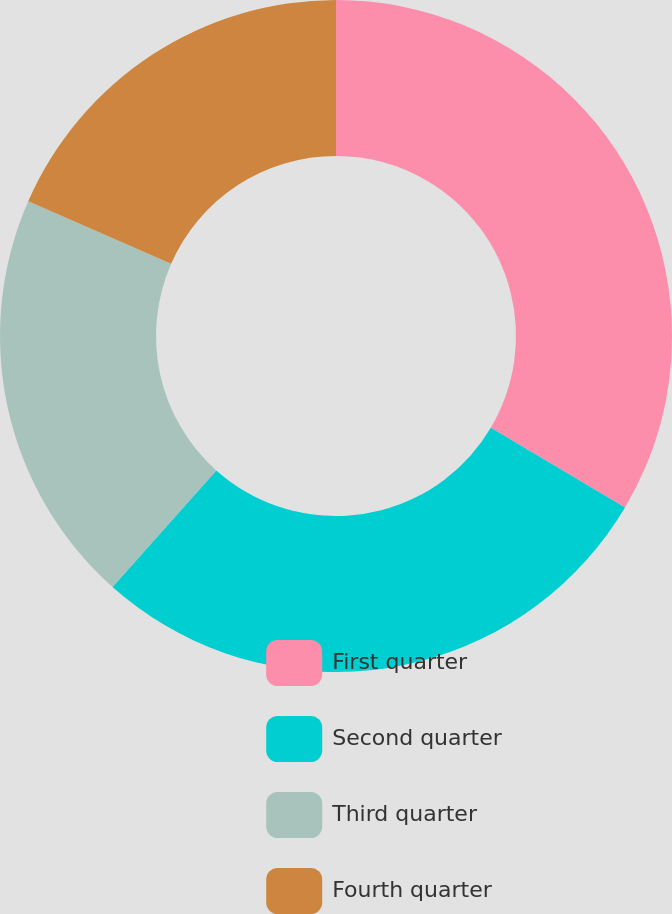<chart> <loc_0><loc_0><loc_500><loc_500><pie_chart><fcel>First quarter<fcel>Second quarter<fcel>Third quarter<fcel>Fourth quarter<nl><fcel>33.52%<fcel>28.06%<fcel>19.99%<fcel>18.43%<nl></chart> 